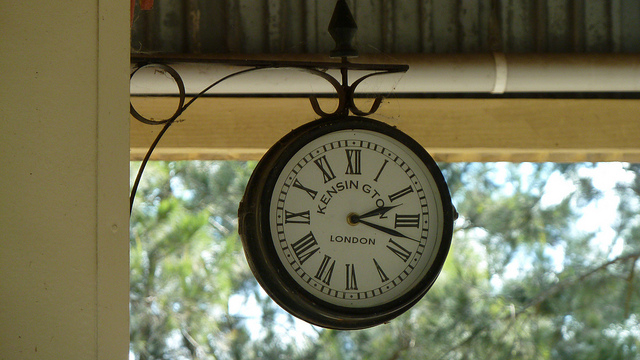Please transcribe the text in this image. XII I II III IV V VI VII VIII XI X XI KENSIN LONDON 